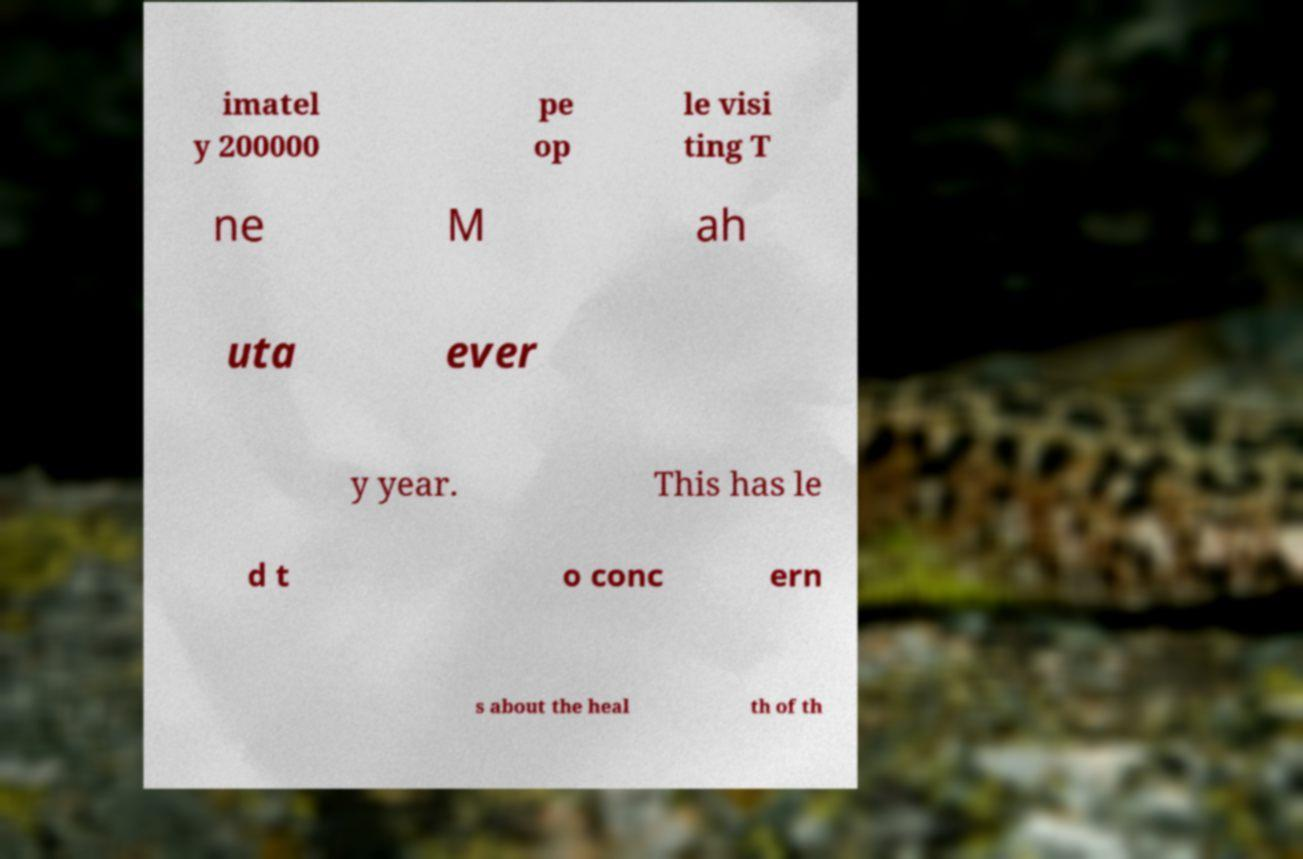Could you assist in decoding the text presented in this image and type it out clearly? imatel y 200000 pe op le visi ting T ne M ah uta ever y year. This has le d t o conc ern s about the heal th of th 